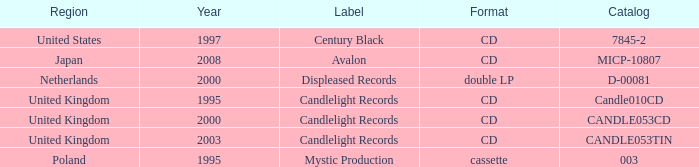What year did Japan form a label? 2008.0. 